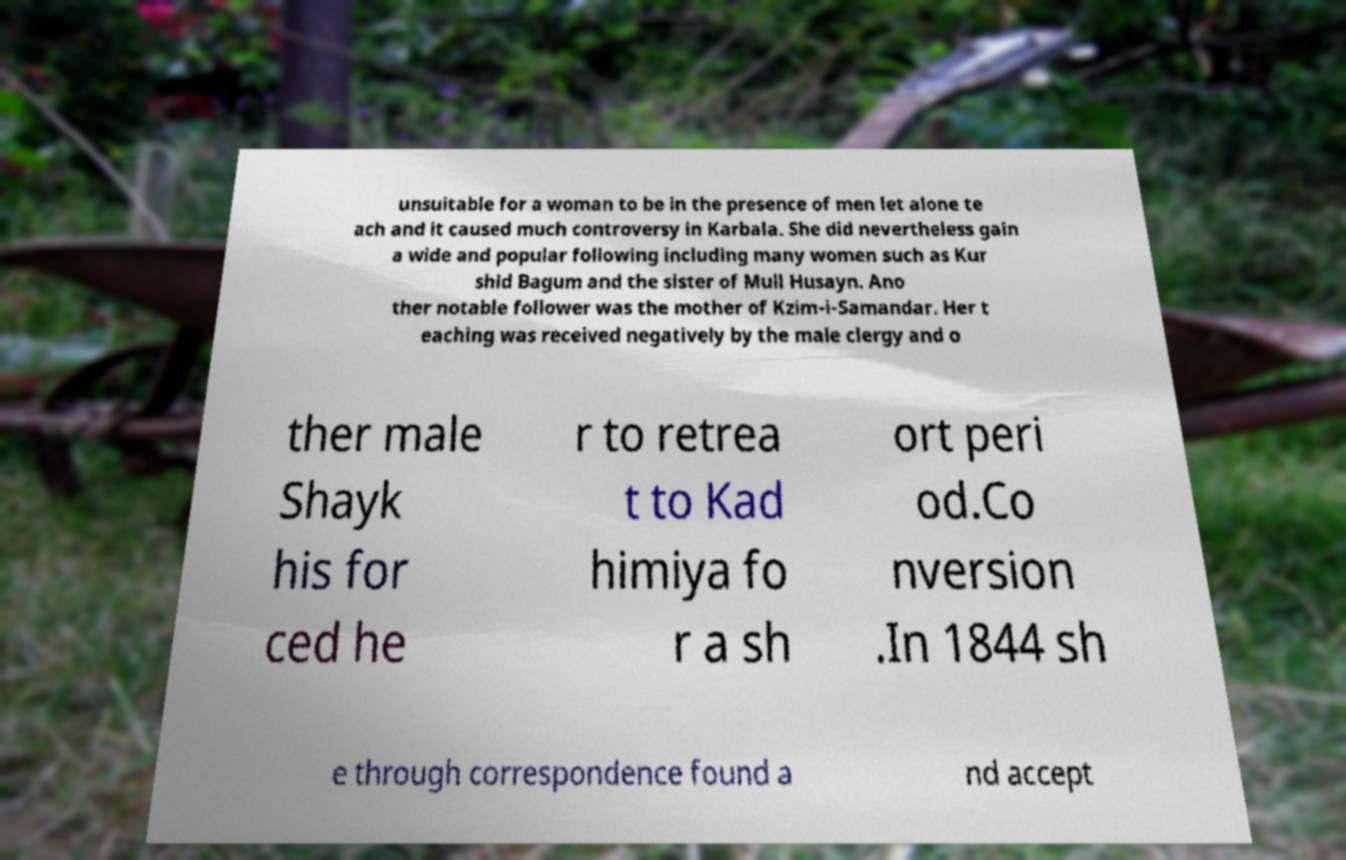I need the written content from this picture converted into text. Can you do that? unsuitable for a woman to be in the presence of men let alone te ach and it caused much controversy in Karbala. She did nevertheless gain a wide and popular following including many women such as Kur shid Bagum and the sister of Mull Husayn. Ano ther notable follower was the mother of Kzim-i-Samandar. Her t eaching was received negatively by the male clergy and o ther male Shayk his for ced he r to retrea t to Kad himiya fo r a sh ort peri od.Co nversion .In 1844 sh e through correspondence found a nd accept 